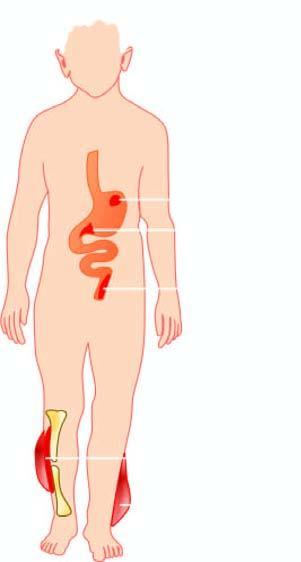s diseases caused by clostridia?
Answer the question using a single word or phrase. Yes 